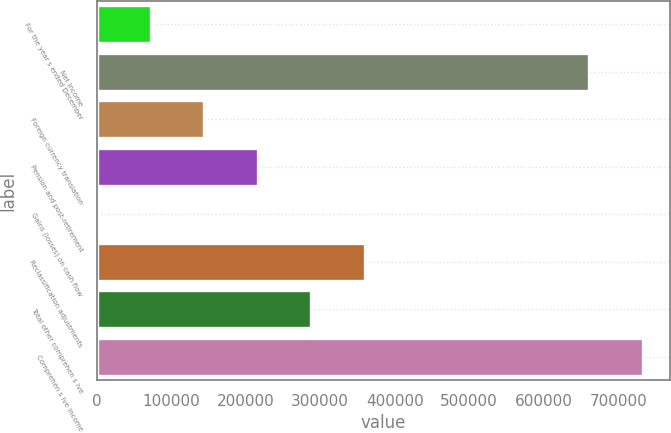Convert chart to OTSL. <chart><loc_0><loc_0><loc_500><loc_500><bar_chart><fcel>For the year s ended December<fcel>Net Income<fcel>Foreign currency translation<fcel>Pension and post-retirement<fcel>Gains (losses) on cash flow<fcel>Reclassification adjustments<fcel>Total other comprehen s ive<fcel>Comprehen s ive income<nl><fcel>72599.8<fcel>660931<fcel>144332<fcel>216063<fcel>868<fcel>359527<fcel>287795<fcel>732663<nl></chart> 